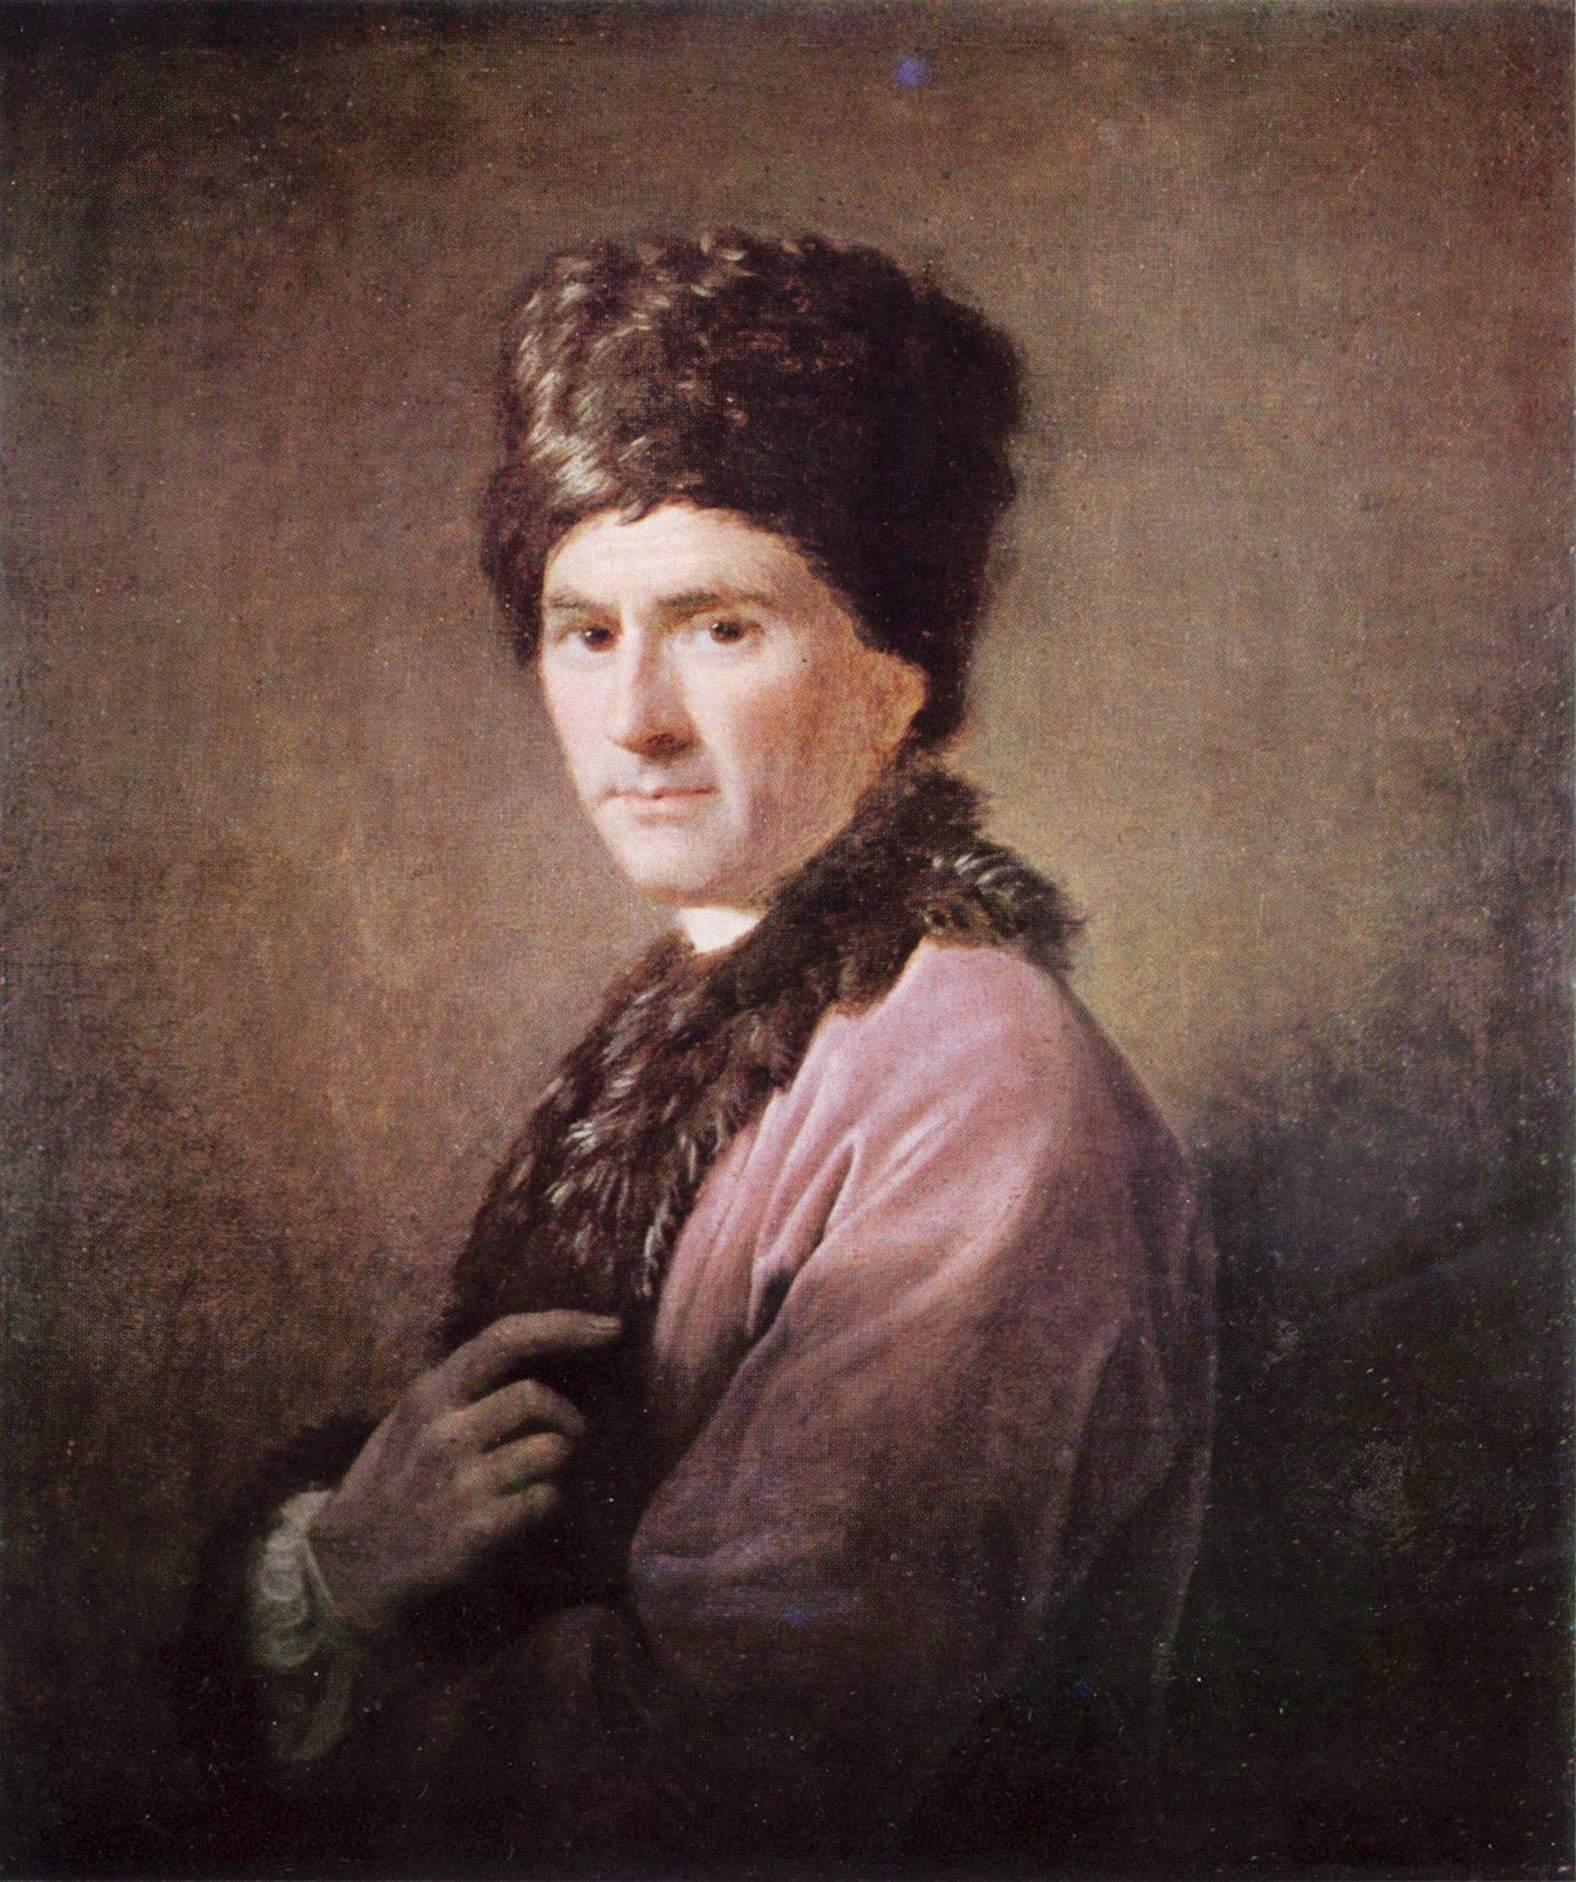What could the expression and gaze of the man in the painting tell us? The man's gaze, directed to the side, implies an engagement with something or someone outside of the painting's frame. It infers a reflective or thoughtful mood and allows the viewer to ponder what might be capturing his attention. Such a contemplative expression enriches the narrative of the portrait by adding a layer of depth to the subject's character. It may hint at a moment captured, where the subject was in mid-thought or reacting to an external stimulus. The subtlety of emotion painted in his expression speaks to the skill of the artist in conveying nuanced human emotions. 